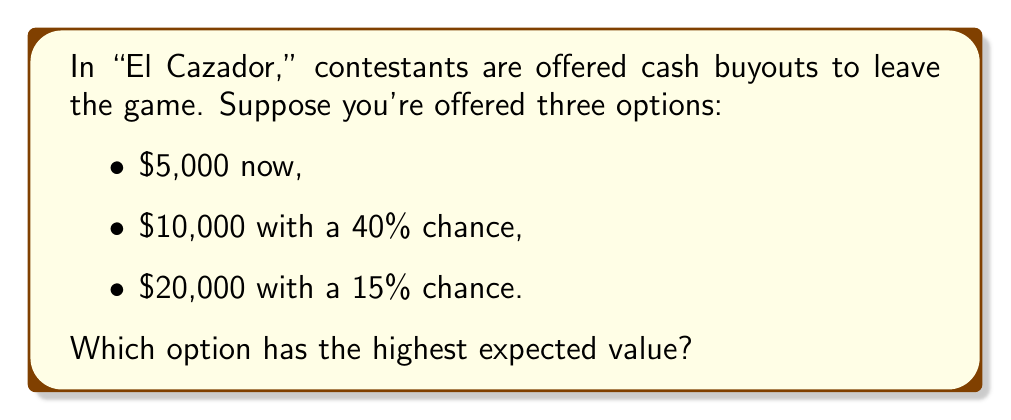Can you answer this question? To solve this problem, we need to calculate the expected value of each option:

1. First option: $5,000 now
   Expected value: $5,000 (100% certain)

2. Second option: $10,000 with 40% chance
   Expected value: $E = 10000 \cdot 0.40 + 0 \cdot 0.60 = 4000$

3. Third option: $20,000 with 15% chance
   Expected value: $E = 20000 \cdot 0.15 + 0 \cdot 0.85 = 3000$

Comparing the expected values:
$$\begin{align}
\text{Option 1}: &\$5,000 \\
\text{Option 2}: &\$4,000 \\
\text{Option 3}: &\$3,000
\end{align}$$

The highest expected value is $5,000, which corresponds to the first option.
Answer: $5,000 (Option 1) 